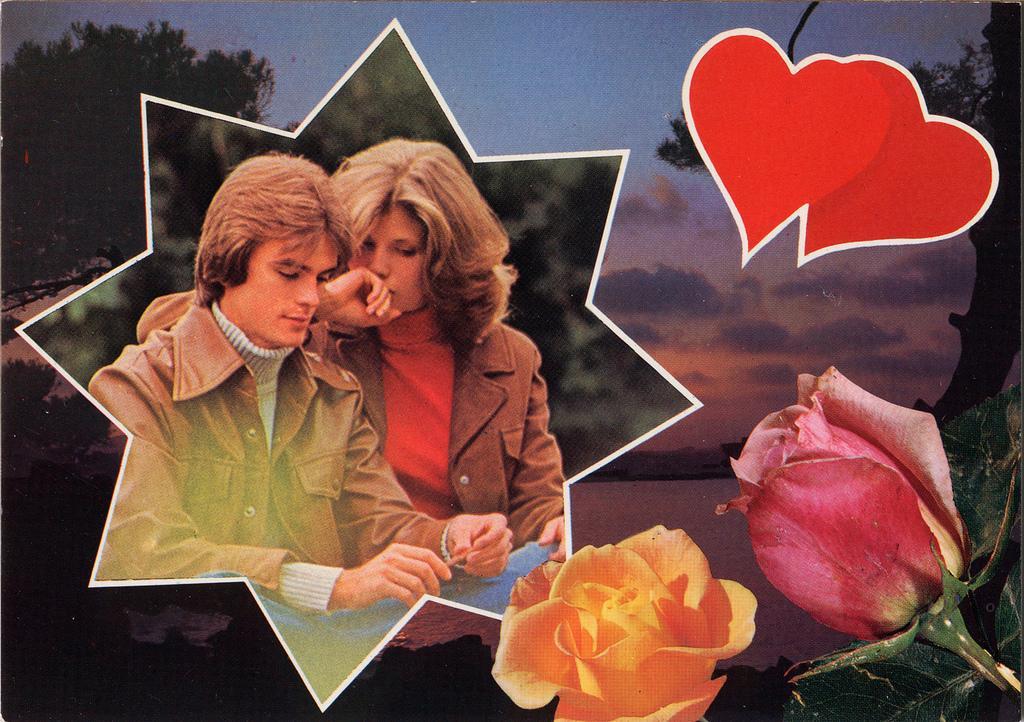Please provide a concise description of this image. In this edited picture there is a man and a woman sitting. In the bottom right there are roses. In the top right there are heart symbols. Behind the roses there is the water. There are trees in the image. At the top there is the sky. 